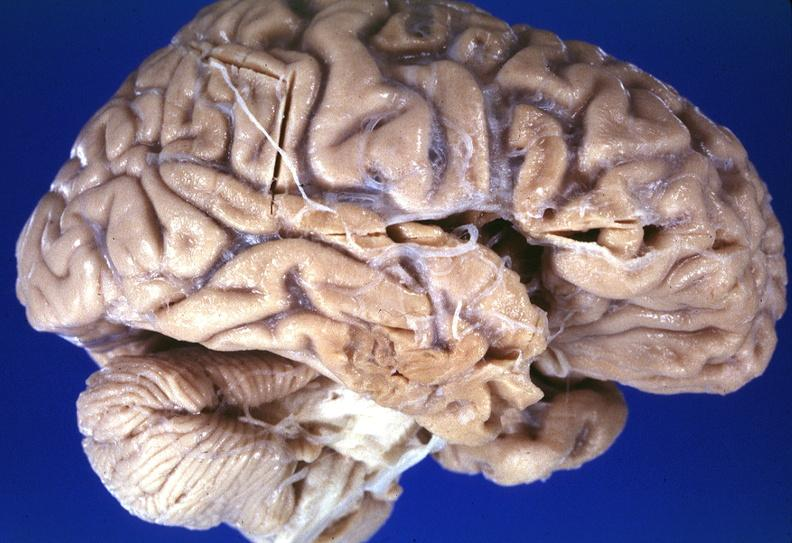what does this image show?
Answer the question using a single word or phrase. Brain 